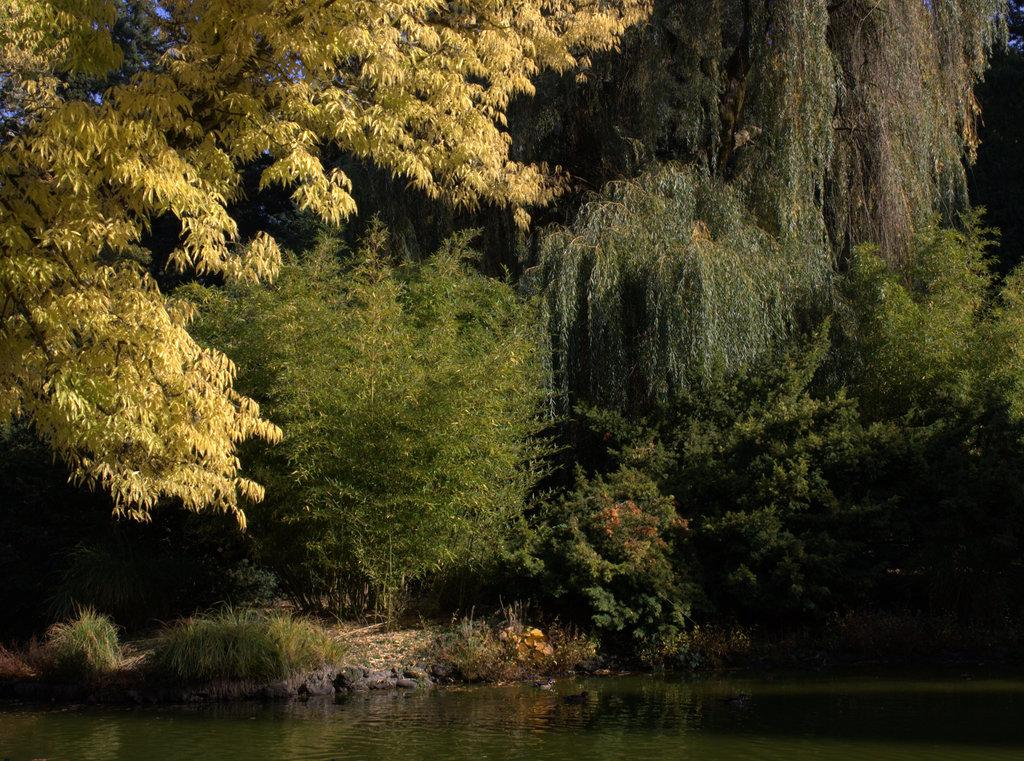What type of vegetation can be seen in the image? There are trees in the image. What natural element is visible in the image? There is water visible in the image. What type of ground cover is present in the image? There is grass in the image. What part of the natural environment is visible in the image? The ground and the sky are visible in the image. What type of muscle can be seen flexing in the image? There is no muscle present in the image; it features trees, water, grass, the ground, and the sky. What type of bulb is visible in the image? There is no bulb present in the image. What type of furniture is visible in the image? There is no furniture present in the image. --- 